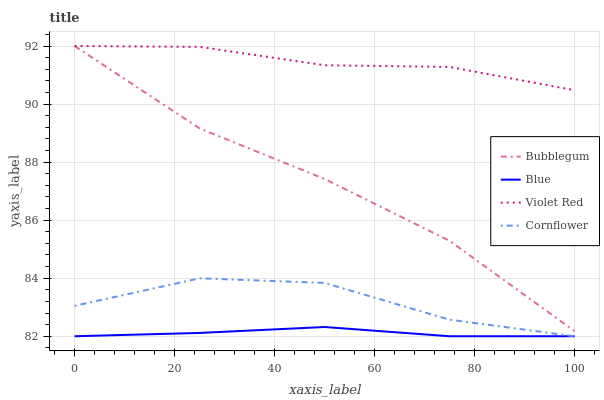Does Blue have the minimum area under the curve?
Answer yes or no. Yes. Does Violet Red have the maximum area under the curve?
Answer yes or no. Yes. Does Cornflower have the minimum area under the curve?
Answer yes or no. No. Does Cornflower have the maximum area under the curve?
Answer yes or no. No. Is Blue the smoothest?
Answer yes or no. Yes. Is Cornflower the roughest?
Answer yes or no. Yes. Is Violet Red the smoothest?
Answer yes or no. No. Is Violet Red the roughest?
Answer yes or no. No. Does Blue have the lowest value?
Answer yes or no. Yes. Does Violet Red have the lowest value?
Answer yes or no. No. Does Bubblegum have the highest value?
Answer yes or no. Yes. Does Cornflower have the highest value?
Answer yes or no. No. Is Cornflower less than Bubblegum?
Answer yes or no. Yes. Is Violet Red greater than Blue?
Answer yes or no. Yes. Does Violet Red intersect Bubblegum?
Answer yes or no. Yes. Is Violet Red less than Bubblegum?
Answer yes or no. No. Is Violet Red greater than Bubblegum?
Answer yes or no. No. Does Cornflower intersect Bubblegum?
Answer yes or no. No. 